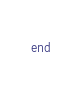<code> <loc_0><loc_0><loc_500><loc_500><_Ruby_>end
</code> 